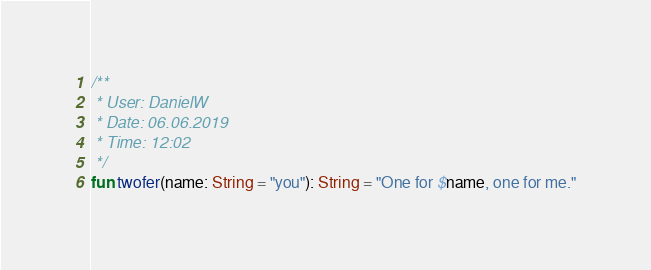Convert code to text. <code><loc_0><loc_0><loc_500><loc_500><_Kotlin_>/**
 * User: DanielW
 * Date: 06.06.2019
 * Time: 12:02
 */
fun twofer(name: String = "you"): String = "One for $name, one for me."
</code> 